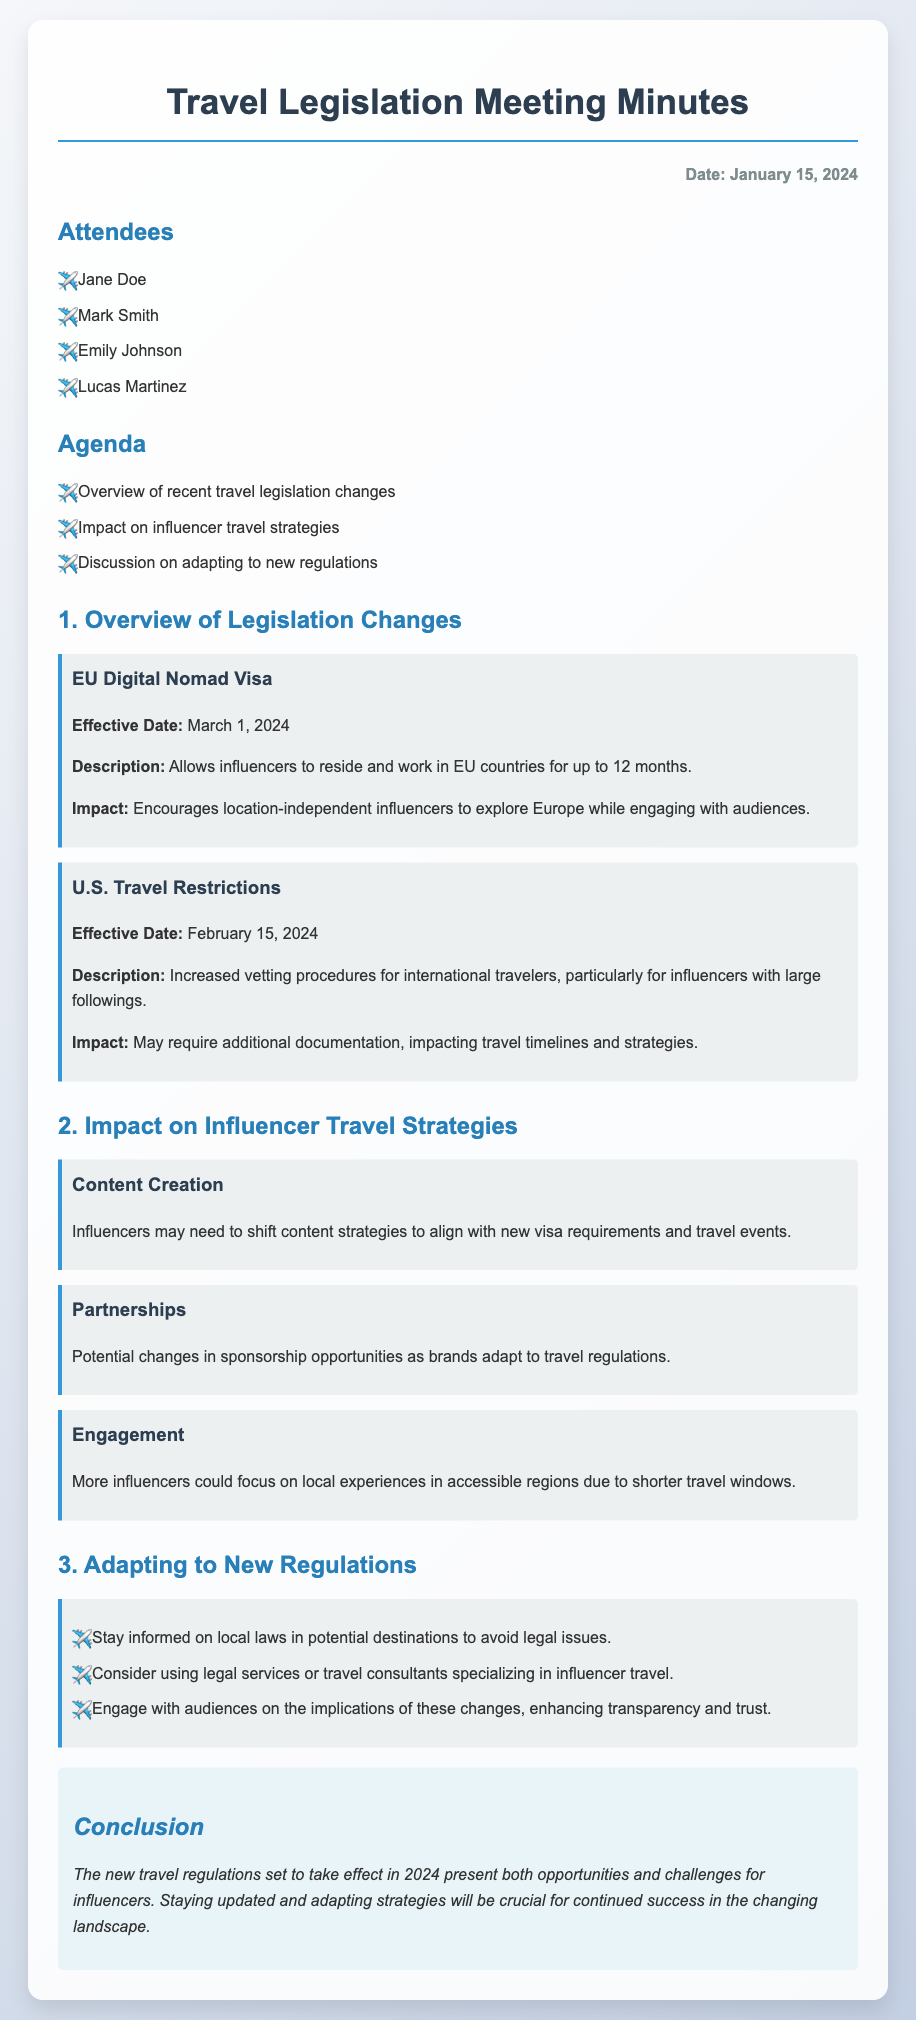What is the effective date for the EU Digital Nomad Visa? The effective date for the EU Digital Nomad Visa is mentioned in the document as March 1, 2024.
Answer: March 1, 2024 What new travel restrictions are implemented in the U.S.? The document states that increased vetting procedures for international travelers will be implemented.
Answer: Increased vetting procedures How long can influencers work under the EU Digital Nomad Visa? The document specifies that influencers can reside and work for up to 12 months under the EU Digital Nomad Visa.
Answer: Up to 12 months What potential change might affect sponsorship opportunities for influencers? The document indicates that there could be changes in sponsorship opportunities as brands adapt to new travel regulations.
Answer: Changes in sponsorship opportunities What focus might influencers shift towards due to shorter travel windows? The document suggests that more influencers could focus on local experiences.
Answer: Local experiences How many attendees were present at the meeting? The document lists four attendees who were present at the meeting.
Answer: Four What is one recommendation for influencers to adapt to new regulations? The document mentions staying informed on local laws in potential destinations as one recommendation.
Answer: Stay informed on local laws What is the main purpose of the meeting as described in the agenda? The agenda outlines an overview of recent travel legislation changes as a primary focus of the meeting.
Answer: Overview of recent travel legislation changes What is the overall conclusion regarding the impact of new travel regulations? The conclusion emphasizes that the new travel regulations present both opportunities and challenges for influencers.
Answer: Opportunities and challenges 